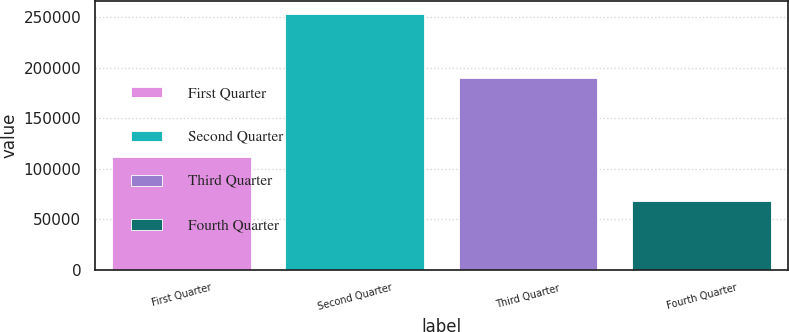<chart> <loc_0><loc_0><loc_500><loc_500><bar_chart><fcel>First Quarter<fcel>Second Quarter<fcel>Third Quarter<fcel>Fourth Quarter<nl><fcel>111606<fcel>253325<fcel>189506<fcel>67610<nl></chart> 